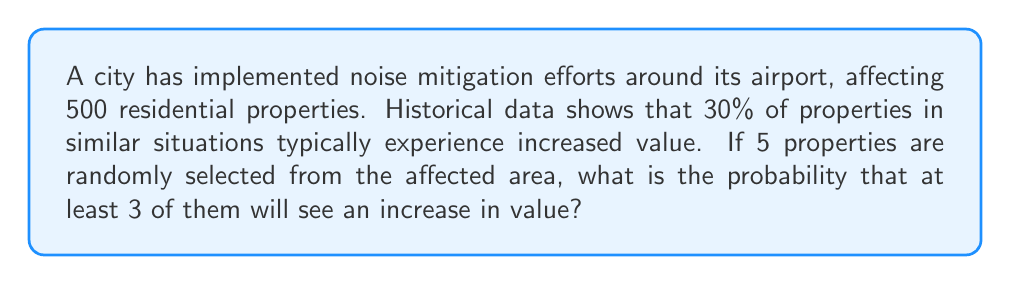Give your solution to this math problem. To solve this problem, we'll use the binomial probability distribution.

Let's define our variables:
$n = 5$ (number of properties selected)
$p = 0.30$ (probability of a property increasing in value)
$q = 1 - p = 0.70$ (probability of a property not increasing in value)

We want to find $P(X \geq 3)$, where $X$ is the number of properties that increase in value.

This can be calculated as:
$P(X \geq 3) = P(X = 3) + P(X = 4) + P(X = 5)$

Using the binomial probability formula:
$P(X = k) = \binom{n}{k} p^k q^{n-k}$

For $k = 3$:
$P(X = 3) = \binom{5}{3} (0.30)^3 (0.70)^2 = 10 \cdot 0.027 \cdot 0.49 = 0.1323$

For $k = 4$:
$P(X = 4) = \binom{5}{4} (0.30)^4 (0.70)^1 = 5 \cdot 0.0081 \cdot 0.70 = 0.02835$

For $k = 5$:
$P(X = 5) = \binom{5}{5} (0.30)^5 (0.70)^0 = 1 \cdot 0.00243 \cdot 1 = 0.00243$

Now, we sum these probabilities:
$P(X \geq 3) = 0.1323 + 0.02835 + 0.00243 = 0.16308$

Therefore, the probability that at least 3 out of 5 randomly selected properties will see an increase in value is approximately 0.16308 or 16.31%.
Answer: 0.16308 